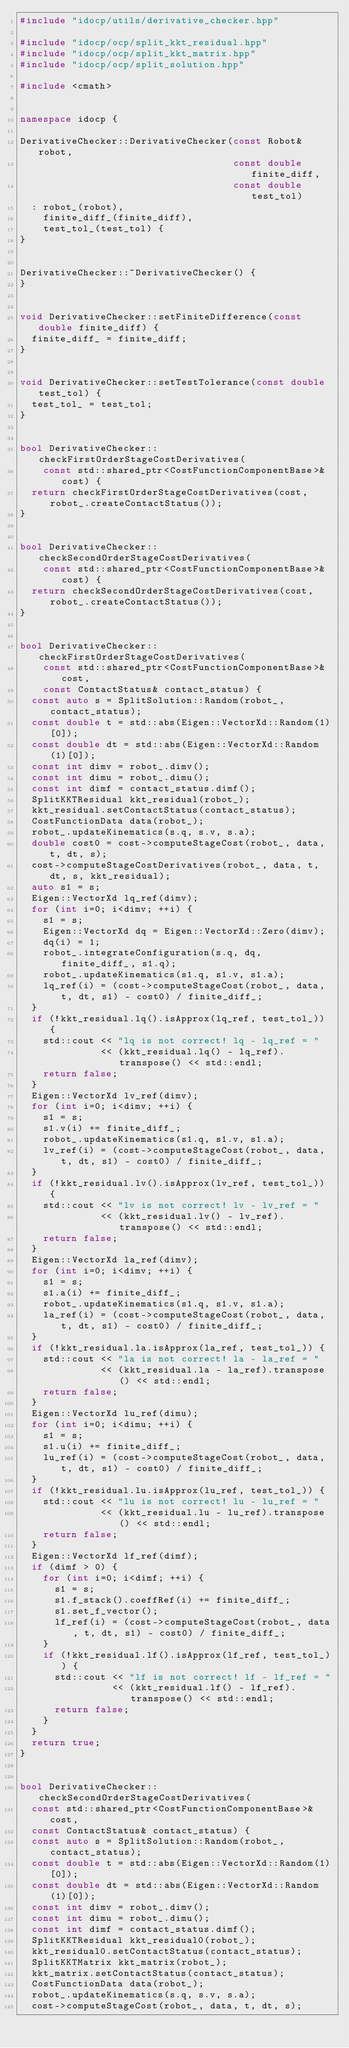Convert code to text. <code><loc_0><loc_0><loc_500><loc_500><_C++_>#include "idocp/utils/derivative_checker.hpp"

#include "idocp/ocp/split_kkt_residual.hpp"
#include "idocp/ocp/split_kkt_matrix.hpp"
#include "idocp/ocp/split_solution.hpp"

#include <cmath>


namespace idocp {

DerivativeChecker::DerivativeChecker(const Robot& robot, 
                                     const double finite_diff, 
                                     const double test_tol)
  : robot_(robot), 
    finite_diff_(finite_diff), 
    test_tol_(test_tol) {
}


DerivativeChecker::~DerivativeChecker() {
}


void DerivativeChecker::setFiniteDifference(const double finite_diff) {
  finite_diff_ = finite_diff;
}


void DerivativeChecker::setTestTolerance(const double test_tol) {
  test_tol_ = test_tol;
}


bool DerivativeChecker::checkFirstOrderStageCostDerivatives(
    const std::shared_ptr<CostFunctionComponentBase>& cost) {
  return checkFirstOrderStageCostDerivatives(cost, robot_.createContactStatus());
}


bool DerivativeChecker::checkSecondOrderStageCostDerivatives(
    const std::shared_ptr<CostFunctionComponentBase>& cost) {
  return checkSecondOrderStageCostDerivatives(cost, robot_.createContactStatus());
}


bool DerivativeChecker::checkFirstOrderStageCostDerivatives(
    const std::shared_ptr<CostFunctionComponentBase>& cost, 
    const ContactStatus& contact_status) {
  const auto s = SplitSolution::Random(robot_, contact_status);
  const double t = std::abs(Eigen::VectorXd::Random(1)[0]);
  const double dt = std::abs(Eigen::VectorXd::Random(1)[0]);
  const int dimv = robot_.dimv();
  const int dimu = robot_.dimu();
  const int dimf = contact_status.dimf();
  SplitKKTResidual kkt_residual(robot_);
  kkt_residual.setContactStatus(contact_status);
  CostFunctionData data(robot_);
  robot_.updateKinematics(s.q, s.v, s.a);
  double cost0 = cost->computeStageCost(robot_, data, t, dt, s);
  cost->computeStageCostDerivatives(robot_, data, t, dt, s, kkt_residual);
  auto s1 = s;
  Eigen::VectorXd lq_ref(dimv);
  for (int i=0; i<dimv; ++i) {
    s1 = s;
    Eigen::VectorXd dq = Eigen::VectorXd::Zero(dimv);
    dq(i) = 1;
    robot_.integrateConfiguration(s.q, dq, finite_diff_, s1.q);
    robot_.updateKinematics(s1.q, s1.v, s1.a);
    lq_ref(i) = (cost->computeStageCost(robot_, data, t, dt, s1) - cost0) / finite_diff_;
  }
  if (!kkt_residual.lq().isApprox(lq_ref, test_tol_)) {
    std::cout << "lq is not correct! lq - lq_ref = " 
              << (kkt_residual.lq() - lq_ref).transpose() << std::endl;
    return false;
  }
  Eigen::VectorXd lv_ref(dimv);
  for (int i=0; i<dimv; ++i) {
    s1 = s;
    s1.v(i) += finite_diff_;
    robot_.updateKinematics(s1.q, s1.v, s1.a);
    lv_ref(i) = (cost->computeStageCost(robot_, data, t, dt, s1) - cost0) / finite_diff_;
  }
  if (!kkt_residual.lv().isApprox(lv_ref, test_tol_)) {
    std::cout << "lv is not correct! lv - lv_ref = " 
              << (kkt_residual.lv() - lv_ref).transpose() << std::endl;
    return false;
  }
  Eigen::VectorXd la_ref(dimv);
  for (int i=0; i<dimv; ++i) {
    s1 = s;
    s1.a(i) += finite_diff_;
    robot_.updateKinematics(s1.q, s1.v, s1.a);
    la_ref(i) = (cost->computeStageCost(robot_, data, t, dt, s1) - cost0) / finite_diff_;
  }
  if (!kkt_residual.la.isApprox(la_ref, test_tol_)) {
    std::cout << "la is not correct! la - la_ref = " 
              << (kkt_residual.la - la_ref).transpose() << std::endl;
    return false;
  }
  Eigen::VectorXd lu_ref(dimu);
  for (int i=0; i<dimu; ++i) {
    s1 = s;
    s1.u(i) += finite_diff_;
    lu_ref(i) = (cost->computeStageCost(robot_, data, t, dt, s1) - cost0) / finite_diff_;
  }
  if (!kkt_residual.lu.isApprox(lu_ref, test_tol_)) {
    std::cout << "lu is not correct! lu - lu_ref = " 
              << (kkt_residual.lu - lu_ref).transpose() << std::endl;
    return false;
  }
  Eigen::VectorXd lf_ref(dimf);
  if (dimf > 0) {
    for (int i=0; i<dimf; ++i) {
      s1 = s;
      s1.f_stack().coeffRef(i) += finite_diff_;
      s1.set_f_vector();
      lf_ref(i) = (cost->computeStageCost(robot_, data, t, dt, s1) - cost0) / finite_diff_;
    }
    if (!kkt_residual.lf().isApprox(lf_ref, test_tol_)) {
      std::cout << "lf is not correct! lf - lf_ref = " 
                << (kkt_residual.lf() - lf_ref).transpose() << std::endl;
      return false;
    }
  }
  return true;
}


bool DerivativeChecker::checkSecondOrderStageCostDerivatives(
  const std::shared_ptr<CostFunctionComponentBase>& cost,
  const ContactStatus& contact_status) {
  const auto s = SplitSolution::Random(robot_, contact_status);
  const double t = std::abs(Eigen::VectorXd::Random(1)[0]);
  const double dt = std::abs(Eigen::VectorXd::Random(1)[0]);
  const int dimv = robot_.dimv();
  const int dimu = robot_.dimu();
  const int dimf = contact_status.dimf();
  SplitKKTResidual kkt_residual0(robot_);
  kkt_residual0.setContactStatus(contact_status);
  SplitKKTMatrix kkt_matrix(robot_);
  kkt_matrix.setContactStatus(contact_status);
  CostFunctionData data(robot_);
  robot_.updateKinematics(s.q, s.v, s.a);
  cost->computeStageCost(robot_, data, t, dt, s);</code> 